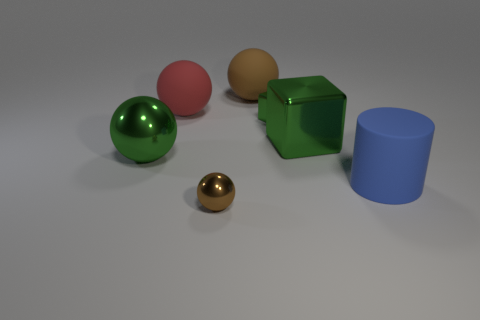There is a tiny thing that is the same color as the big block; what is its shape?
Offer a terse response. Cube. Do the big metal ball and the large cube have the same color?
Offer a very short reply. Yes. Do the big green thing behind the big green ball and the big green thing in front of the big shiny cube have the same material?
Provide a succinct answer. Yes. What number of things are either big metal things that are on the right side of the tiny brown metal sphere or green things?
Your response must be concise. 3. Is the number of brown matte spheres that are behind the tiny brown sphere less than the number of big spheres that are behind the green ball?
Provide a short and direct response. Yes. What number of other objects are the same size as the blue rubber object?
Keep it short and to the point. 4. Are the red thing and the green thing that is on the left side of the tiny brown shiny sphere made of the same material?
Offer a very short reply. No. How many objects are brown objects that are to the left of the brown matte ball or things to the left of the small shiny block?
Your answer should be compact. 4. The big rubber cylinder has what color?
Your response must be concise. Blue. Are there fewer things to the right of the big red rubber thing than large red matte objects?
Your answer should be compact. No. 